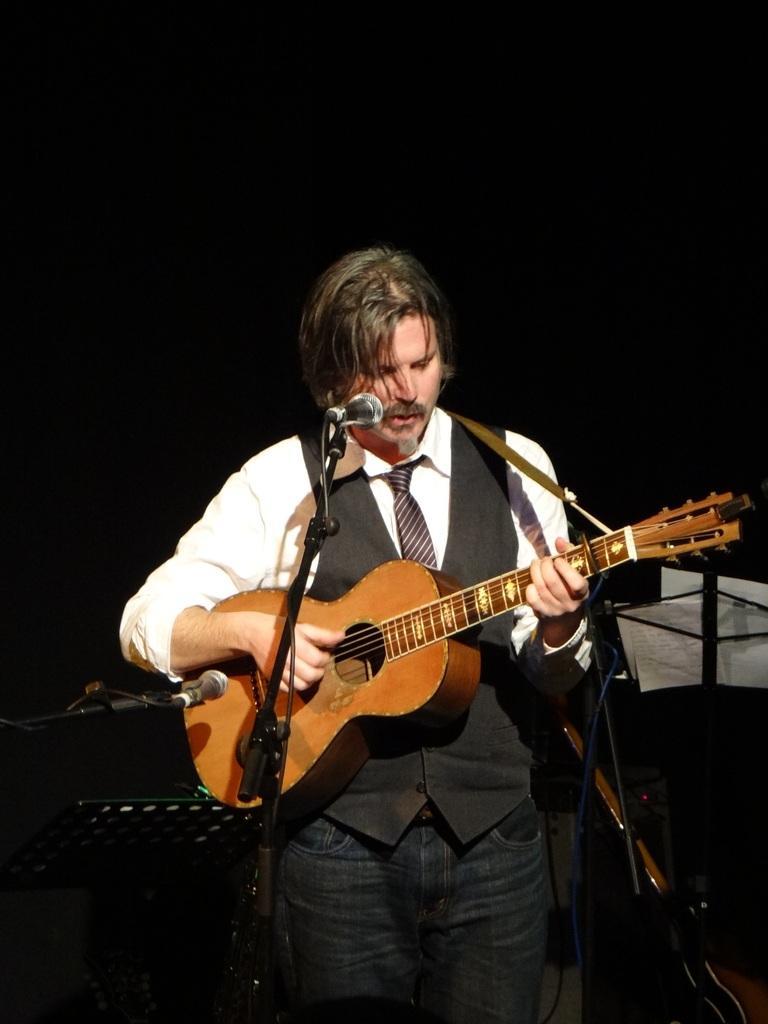Could you give a brief overview of what you see in this image? In this image there is a person standing at the center who is singing and playing a guitar. There is a microphone present in front of him and a stand. Behind him at the right there are paper notes. 